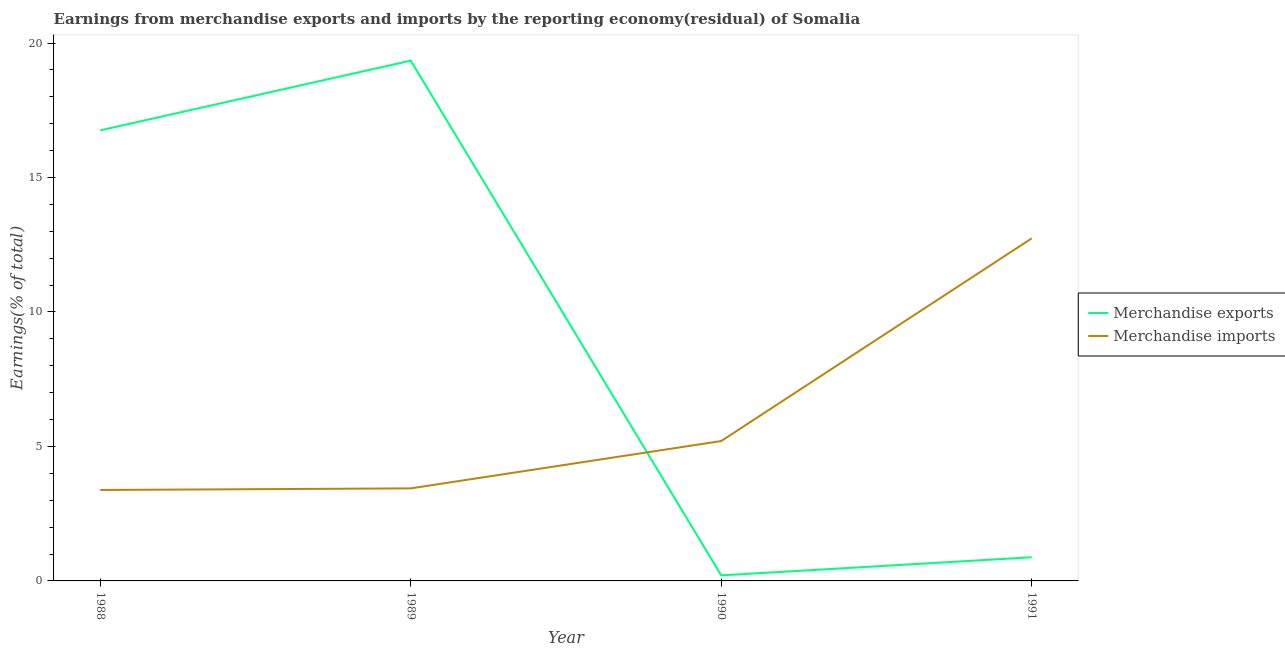How many different coloured lines are there?
Give a very brief answer. 2. Does the line corresponding to earnings from merchandise exports intersect with the line corresponding to earnings from merchandise imports?
Provide a short and direct response. Yes. Is the number of lines equal to the number of legend labels?
Give a very brief answer. Yes. What is the earnings from merchandise imports in 1990?
Your response must be concise. 5.2. Across all years, what is the maximum earnings from merchandise exports?
Your answer should be compact. 19.35. Across all years, what is the minimum earnings from merchandise imports?
Offer a terse response. 3.38. In which year was the earnings from merchandise imports maximum?
Ensure brevity in your answer.  1991. In which year was the earnings from merchandise imports minimum?
Offer a very short reply. 1988. What is the total earnings from merchandise imports in the graph?
Provide a succinct answer. 24.76. What is the difference between the earnings from merchandise exports in 1989 and that in 1990?
Provide a succinct answer. 19.14. What is the difference between the earnings from merchandise imports in 1989 and the earnings from merchandise exports in 1990?
Ensure brevity in your answer.  3.23. What is the average earnings from merchandise exports per year?
Ensure brevity in your answer.  9.3. In the year 1990, what is the difference between the earnings from merchandise exports and earnings from merchandise imports?
Provide a short and direct response. -4.99. In how many years, is the earnings from merchandise imports greater than 6 %?
Offer a terse response. 1. What is the ratio of the earnings from merchandise exports in 1988 to that in 1989?
Offer a terse response. 0.87. Is the earnings from merchandise exports in 1989 less than that in 1990?
Your response must be concise. No. Is the difference between the earnings from merchandise exports in 1989 and 1991 greater than the difference between the earnings from merchandise imports in 1989 and 1991?
Your answer should be compact. Yes. What is the difference between the highest and the second highest earnings from merchandise exports?
Give a very brief answer. 2.59. What is the difference between the highest and the lowest earnings from merchandise exports?
Offer a terse response. 19.14. Is the sum of the earnings from merchandise imports in 1988 and 1990 greater than the maximum earnings from merchandise exports across all years?
Provide a succinct answer. No. Does the earnings from merchandise imports monotonically increase over the years?
Your answer should be compact. Yes. Is the earnings from merchandise exports strictly less than the earnings from merchandise imports over the years?
Ensure brevity in your answer.  No. How many lines are there?
Make the answer very short. 2. What is the title of the graph?
Give a very brief answer. Earnings from merchandise exports and imports by the reporting economy(residual) of Somalia. What is the label or title of the X-axis?
Offer a very short reply. Year. What is the label or title of the Y-axis?
Keep it short and to the point. Earnings(% of total). What is the Earnings(% of total) in Merchandise exports in 1988?
Make the answer very short. 16.75. What is the Earnings(% of total) of Merchandise imports in 1988?
Your answer should be very brief. 3.38. What is the Earnings(% of total) in Merchandise exports in 1989?
Provide a short and direct response. 19.35. What is the Earnings(% of total) in Merchandise imports in 1989?
Offer a very short reply. 3.44. What is the Earnings(% of total) of Merchandise exports in 1990?
Ensure brevity in your answer.  0.21. What is the Earnings(% of total) of Merchandise imports in 1990?
Offer a terse response. 5.2. What is the Earnings(% of total) of Merchandise exports in 1991?
Offer a very short reply. 0.88. What is the Earnings(% of total) in Merchandise imports in 1991?
Provide a short and direct response. 12.74. Across all years, what is the maximum Earnings(% of total) of Merchandise exports?
Provide a succinct answer. 19.35. Across all years, what is the maximum Earnings(% of total) in Merchandise imports?
Provide a succinct answer. 12.74. Across all years, what is the minimum Earnings(% of total) in Merchandise exports?
Offer a very short reply. 0.21. Across all years, what is the minimum Earnings(% of total) of Merchandise imports?
Your answer should be very brief. 3.38. What is the total Earnings(% of total) in Merchandise exports in the graph?
Your answer should be compact. 37.18. What is the total Earnings(% of total) of Merchandise imports in the graph?
Provide a short and direct response. 24.76. What is the difference between the Earnings(% of total) in Merchandise exports in 1988 and that in 1989?
Ensure brevity in your answer.  -2.59. What is the difference between the Earnings(% of total) of Merchandise imports in 1988 and that in 1989?
Make the answer very short. -0.06. What is the difference between the Earnings(% of total) in Merchandise exports in 1988 and that in 1990?
Your answer should be very brief. 16.55. What is the difference between the Earnings(% of total) of Merchandise imports in 1988 and that in 1990?
Your response must be concise. -1.82. What is the difference between the Earnings(% of total) in Merchandise exports in 1988 and that in 1991?
Offer a terse response. 15.87. What is the difference between the Earnings(% of total) of Merchandise imports in 1988 and that in 1991?
Give a very brief answer. -9.35. What is the difference between the Earnings(% of total) in Merchandise exports in 1989 and that in 1990?
Offer a terse response. 19.14. What is the difference between the Earnings(% of total) of Merchandise imports in 1989 and that in 1990?
Offer a terse response. -1.76. What is the difference between the Earnings(% of total) in Merchandise exports in 1989 and that in 1991?
Make the answer very short. 18.47. What is the difference between the Earnings(% of total) of Merchandise imports in 1989 and that in 1991?
Make the answer very short. -9.29. What is the difference between the Earnings(% of total) in Merchandise exports in 1990 and that in 1991?
Provide a short and direct response. -0.67. What is the difference between the Earnings(% of total) of Merchandise imports in 1990 and that in 1991?
Keep it short and to the point. -7.54. What is the difference between the Earnings(% of total) of Merchandise exports in 1988 and the Earnings(% of total) of Merchandise imports in 1989?
Provide a short and direct response. 13.31. What is the difference between the Earnings(% of total) of Merchandise exports in 1988 and the Earnings(% of total) of Merchandise imports in 1990?
Your answer should be very brief. 11.55. What is the difference between the Earnings(% of total) in Merchandise exports in 1988 and the Earnings(% of total) in Merchandise imports in 1991?
Provide a short and direct response. 4.02. What is the difference between the Earnings(% of total) of Merchandise exports in 1989 and the Earnings(% of total) of Merchandise imports in 1990?
Provide a short and direct response. 14.14. What is the difference between the Earnings(% of total) of Merchandise exports in 1989 and the Earnings(% of total) of Merchandise imports in 1991?
Your answer should be compact. 6.61. What is the difference between the Earnings(% of total) of Merchandise exports in 1990 and the Earnings(% of total) of Merchandise imports in 1991?
Offer a very short reply. -12.53. What is the average Earnings(% of total) of Merchandise exports per year?
Provide a succinct answer. 9.3. What is the average Earnings(% of total) of Merchandise imports per year?
Your answer should be compact. 6.19. In the year 1988, what is the difference between the Earnings(% of total) in Merchandise exports and Earnings(% of total) in Merchandise imports?
Provide a short and direct response. 13.37. In the year 1989, what is the difference between the Earnings(% of total) of Merchandise exports and Earnings(% of total) of Merchandise imports?
Provide a succinct answer. 15.9. In the year 1990, what is the difference between the Earnings(% of total) in Merchandise exports and Earnings(% of total) in Merchandise imports?
Offer a terse response. -4.99. In the year 1991, what is the difference between the Earnings(% of total) in Merchandise exports and Earnings(% of total) in Merchandise imports?
Give a very brief answer. -11.86. What is the ratio of the Earnings(% of total) of Merchandise exports in 1988 to that in 1989?
Provide a succinct answer. 0.87. What is the ratio of the Earnings(% of total) in Merchandise imports in 1988 to that in 1989?
Your answer should be very brief. 0.98. What is the ratio of the Earnings(% of total) of Merchandise exports in 1988 to that in 1990?
Your answer should be compact. 81.24. What is the ratio of the Earnings(% of total) of Merchandise imports in 1988 to that in 1990?
Your response must be concise. 0.65. What is the ratio of the Earnings(% of total) of Merchandise exports in 1988 to that in 1991?
Your answer should be compact. 19.05. What is the ratio of the Earnings(% of total) in Merchandise imports in 1988 to that in 1991?
Offer a terse response. 0.27. What is the ratio of the Earnings(% of total) in Merchandise exports in 1989 to that in 1990?
Provide a succinct answer. 93.81. What is the ratio of the Earnings(% of total) of Merchandise imports in 1989 to that in 1990?
Provide a succinct answer. 0.66. What is the ratio of the Earnings(% of total) of Merchandise exports in 1989 to that in 1991?
Keep it short and to the point. 22. What is the ratio of the Earnings(% of total) of Merchandise imports in 1989 to that in 1991?
Provide a succinct answer. 0.27. What is the ratio of the Earnings(% of total) of Merchandise exports in 1990 to that in 1991?
Provide a short and direct response. 0.23. What is the ratio of the Earnings(% of total) of Merchandise imports in 1990 to that in 1991?
Offer a terse response. 0.41. What is the difference between the highest and the second highest Earnings(% of total) in Merchandise exports?
Provide a short and direct response. 2.59. What is the difference between the highest and the second highest Earnings(% of total) in Merchandise imports?
Provide a short and direct response. 7.54. What is the difference between the highest and the lowest Earnings(% of total) in Merchandise exports?
Give a very brief answer. 19.14. What is the difference between the highest and the lowest Earnings(% of total) in Merchandise imports?
Offer a terse response. 9.35. 